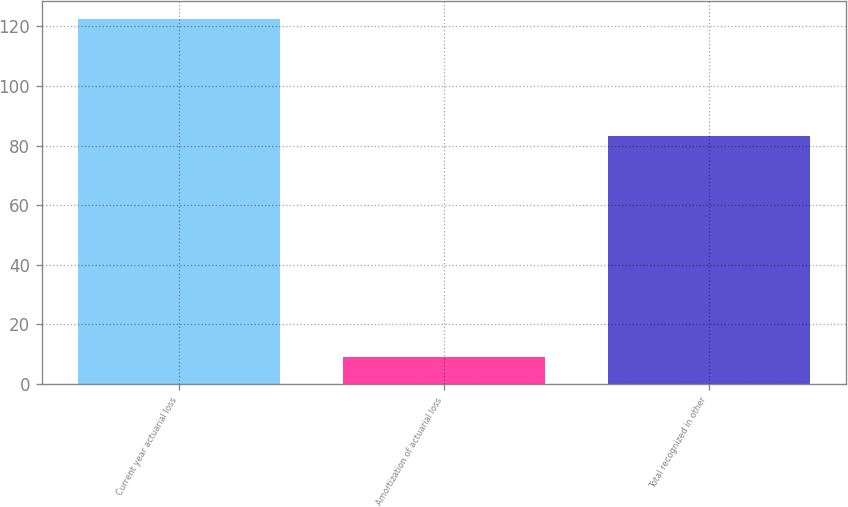<chart> <loc_0><loc_0><loc_500><loc_500><bar_chart><fcel>Current year actuarial loss<fcel>Amortization of actuarial loss<fcel>Total recognized in other<nl><fcel>122.5<fcel>9.1<fcel>83.2<nl></chart> 